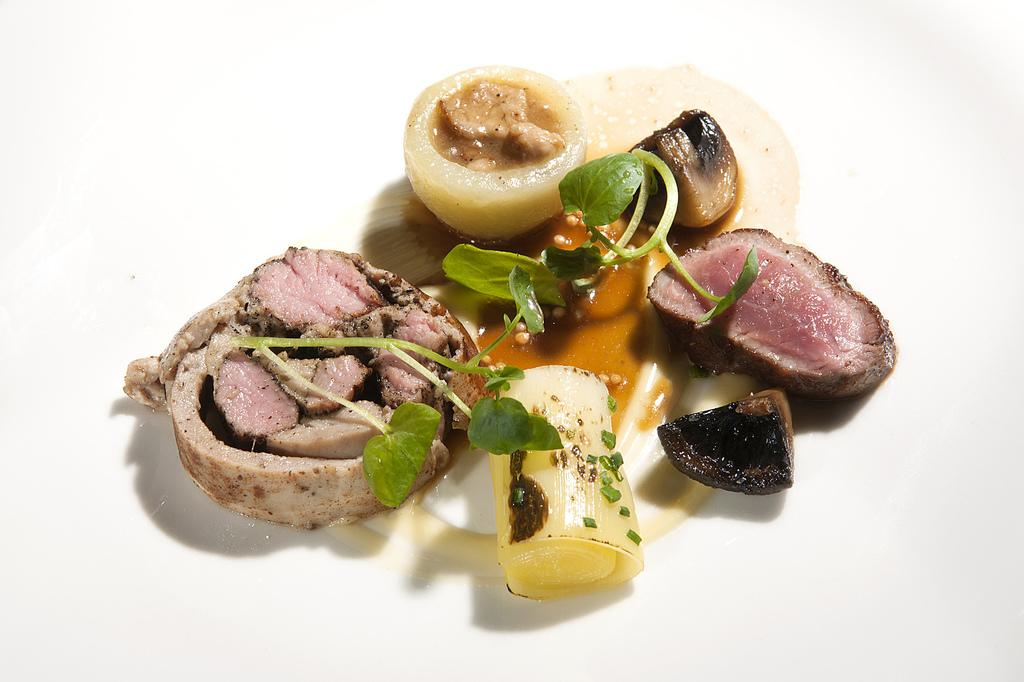What is the color of the surface in the image? The surface in the image is white. What can be found on the white surface? There is food on the surface. Can you describe the colors of the food? The food has brown, pink, yellow, and black colors. What else is visible in the image besides the food? There are leaves visible in the image. What type of record is being played on the white surface in the image? There is no record or music player present in the image; it only features food and leaves on a white surface. 